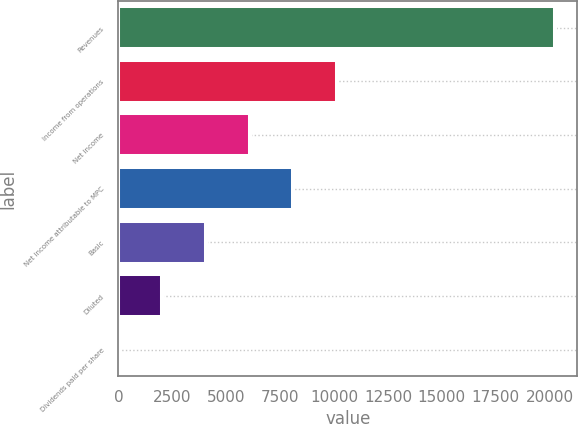Convert chart. <chart><loc_0><loc_0><loc_500><loc_500><bar_chart><fcel>Revenues<fcel>Income from operations<fcel>Net income<fcel>Net income attributable to MPC<fcel>Basic<fcel>Diluted<fcel>Dividends paid per share<nl><fcel>20265<fcel>10132.6<fcel>6079.68<fcel>8106.16<fcel>4053.2<fcel>2026.73<fcel>0.25<nl></chart> 